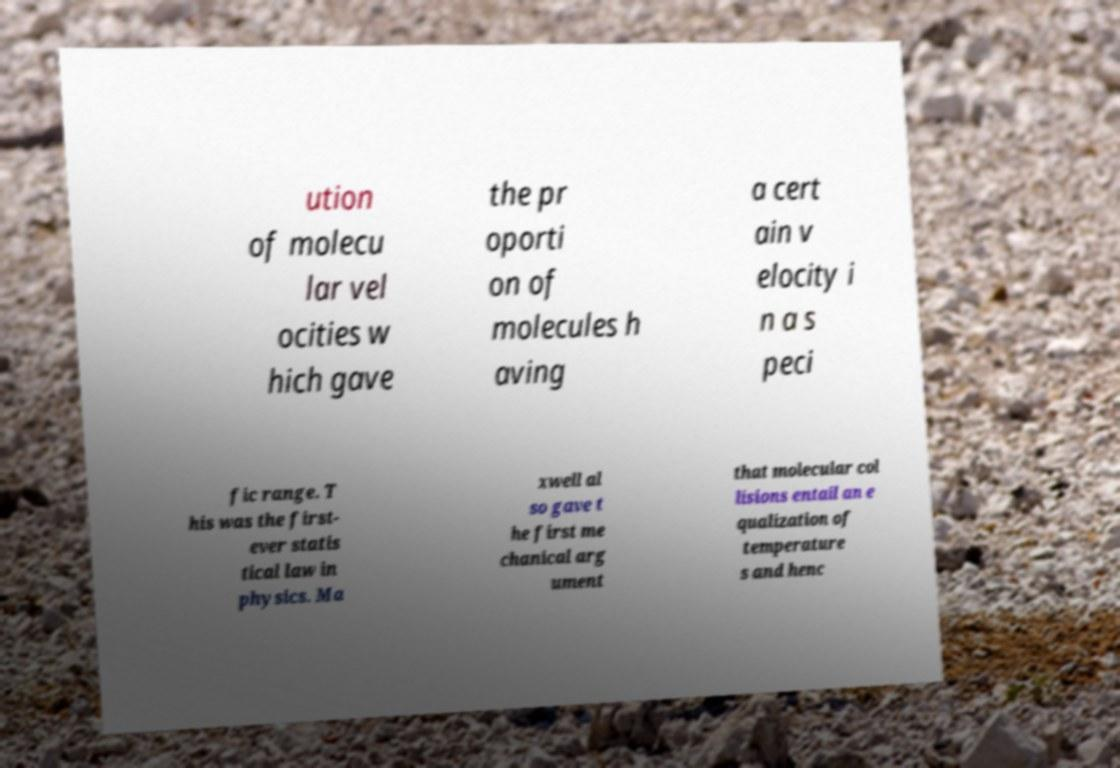I need the written content from this picture converted into text. Can you do that? ution of molecu lar vel ocities w hich gave the pr oporti on of molecules h aving a cert ain v elocity i n a s peci fic range. T his was the first- ever statis tical law in physics. Ma xwell al so gave t he first me chanical arg ument that molecular col lisions entail an e qualization of temperature s and henc 